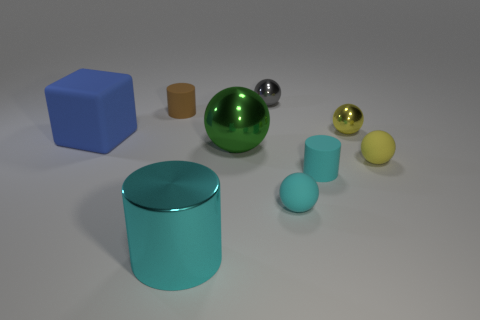What materials are represented by the objects in the scene? The objects in the image seem to showcase various materials: there is a cube with a matte texture, a cylinder with a glossy, reflective surface, and spheres that appear to have both matte and metallic finishes. 